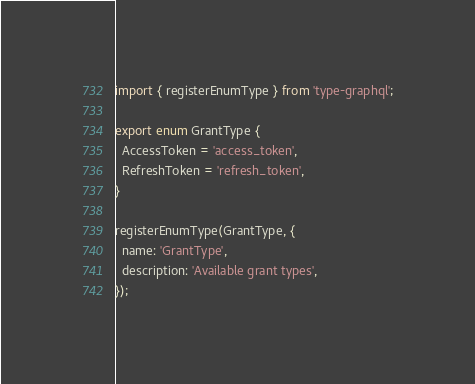Convert code to text. <code><loc_0><loc_0><loc_500><loc_500><_TypeScript_>import { registerEnumType } from 'type-graphql';

export enum GrantType {
  AccessToken = 'access_token',
  RefreshToken = 'refresh_token',
}

registerEnumType(GrantType, {
  name: 'GrantType',
  description: 'Available grant types',
});
</code> 